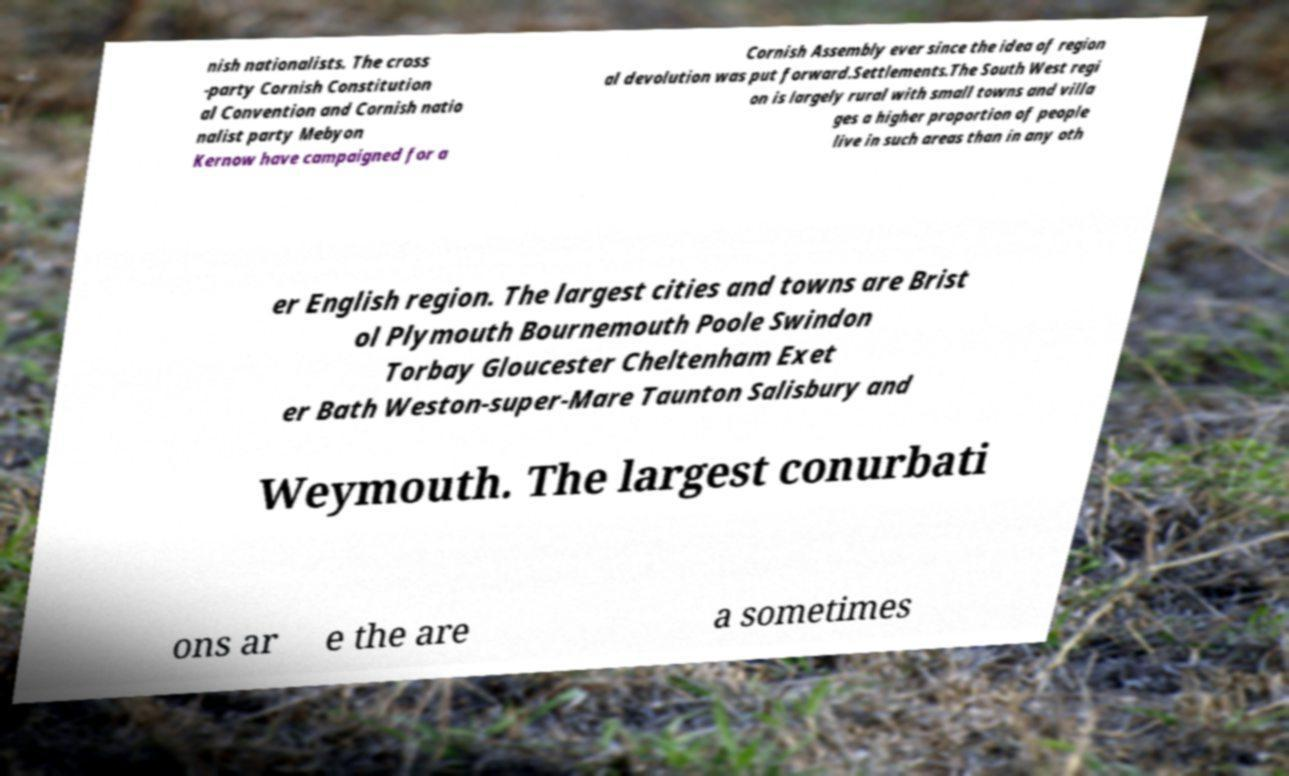For documentation purposes, I need the text within this image transcribed. Could you provide that? nish nationalists. The cross -party Cornish Constitution al Convention and Cornish natio nalist party Mebyon Kernow have campaigned for a Cornish Assembly ever since the idea of region al devolution was put forward.Settlements.The South West regi on is largely rural with small towns and villa ges a higher proportion of people live in such areas than in any oth er English region. The largest cities and towns are Brist ol Plymouth Bournemouth Poole Swindon Torbay Gloucester Cheltenham Exet er Bath Weston-super-Mare Taunton Salisbury and Weymouth. The largest conurbati ons ar e the are a sometimes 